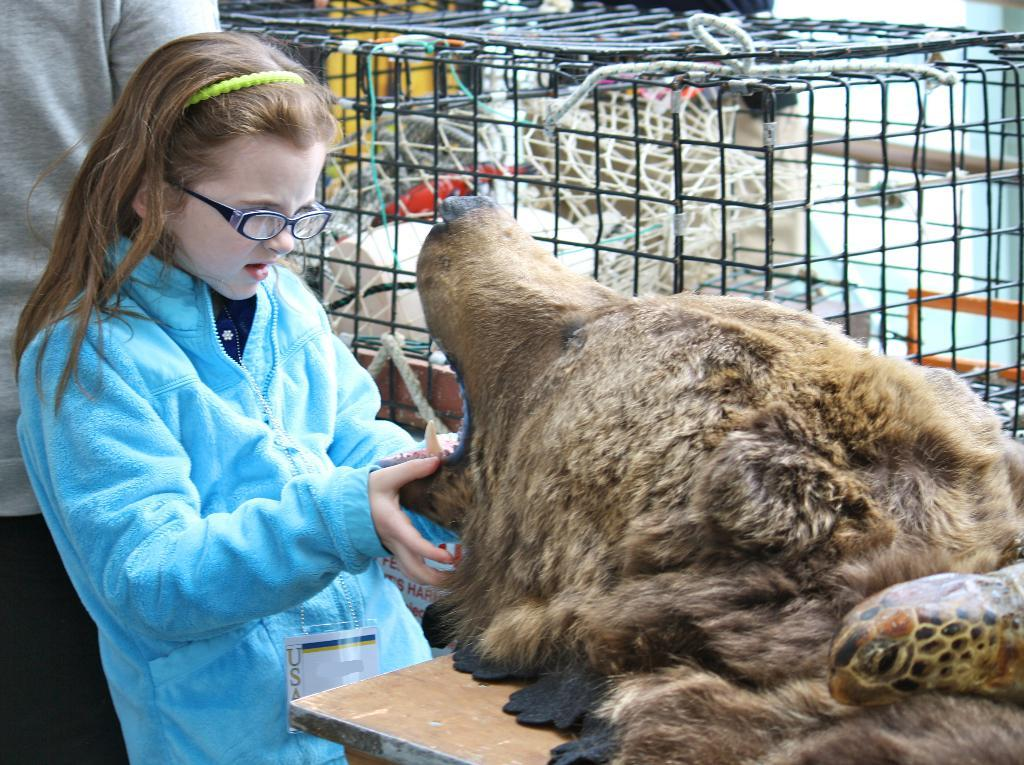What type of animal is present in the image? There is a dog in the image. What piece of furniture is in the image? There is a table in the image. Who is the person in the image? There is a girl in the image. What is the girl wearing? The girl is wearing a jacket and spectacles. What is the girl doing in the image? The girl is looking at the dog. What is the mesh used for in the image? The mesh is not mentioned in the provided facts, so we cannot determine its purpose. What type of operation is the dog undergoing in the image? There is no indication of an operation in the image; the dog is simply present with the girl. What type of pen is the girl using to write on the dog's bone in the image? There is no pen or bone present in the image; the girl is looking at the dog while wearing a jacket and spectacles. 